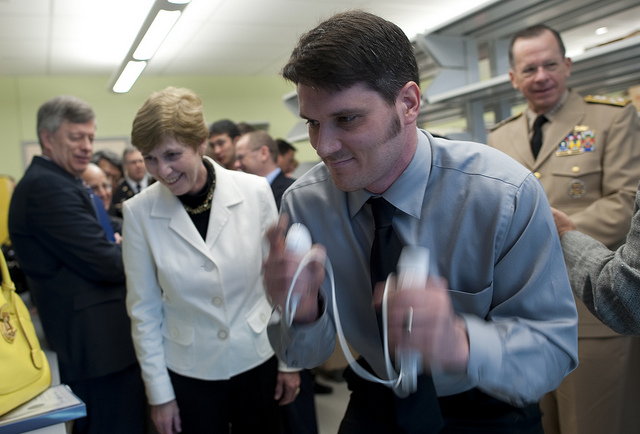What activity are the people engaged in? Though the image doesn't provide explicit details, it does show a group of people including a man at the forefront who seems to be conducting an experiment or demonstration, whilst individuals in the background look on with interest. 